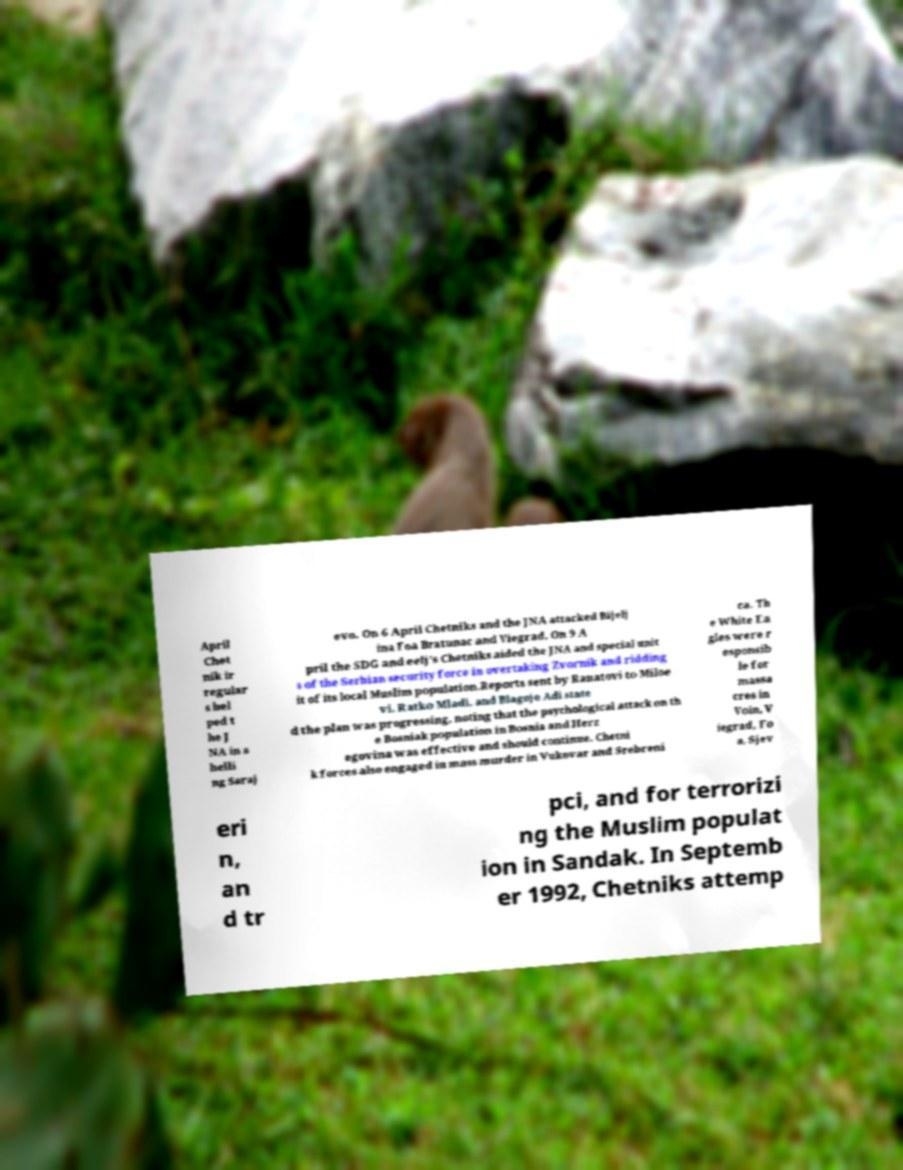What messages or text are displayed in this image? I need them in a readable, typed format. April Chet nik ir regular s hel ped t he J NA in s helli ng Saraj evo. On 6 April Chetniks and the JNA attacked Bijelj ina Foa Bratunac and Viegrad. On 9 A pril the SDG and eelj's Chetniks aided the JNA and special unit s of the Serbian security force in overtaking Zvornik and ridding it of its local Muslim population.Reports sent by Ranatovi to Miloe vi, Ratko Mladi, and Blagoje Adi state d the plan was progressing, noting that the psychological attack on th e Bosniak population in Bosnia and Herz egovina was effective and should continue. Chetni k forces also engaged in mass murder in Vukovar and Srebreni ca. Th e White Ea gles were r esponsib le for massa cres in Voin, V iegrad, Fo a, Sjev eri n, an d tr pci, and for terrorizi ng the Muslim populat ion in Sandak. In Septemb er 1992, Chetniks attemp 